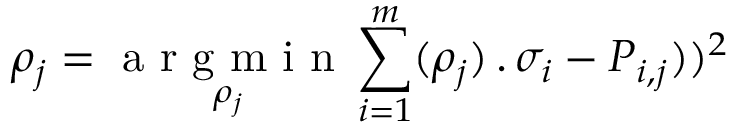<formula> <loc_0><loc_0><loc_500><loc_500>\rho _ { j } = { \underset { \rho _ { j } } { a r g m i n } } \sum _ { i = 1 } ^ { m } ( { \rho _ { j } ) } \, . \, { \sigma _ { i } } - P _ { i , j } ) ) ^ { 2 }</formula> 